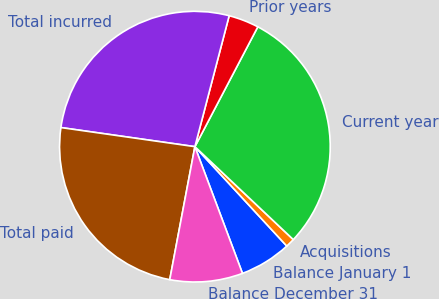Convert chart to OTSL. <chart><loc_0><loc_0><loc_500><loc_500><pie_chart><fcel>Balance January 1<fcel>Acquisitions<fcel>Current year<fcel>Prior years<fcel>Total incurred<fcel>Total paid<fcel>Balance December 31<nl><fcel>6.16%<fcel>1.08%<fcel>29.35%<fcel>3.62%<fcel>26.82%<fcel>24.28%<fcel>8.69%<nl></chart> 